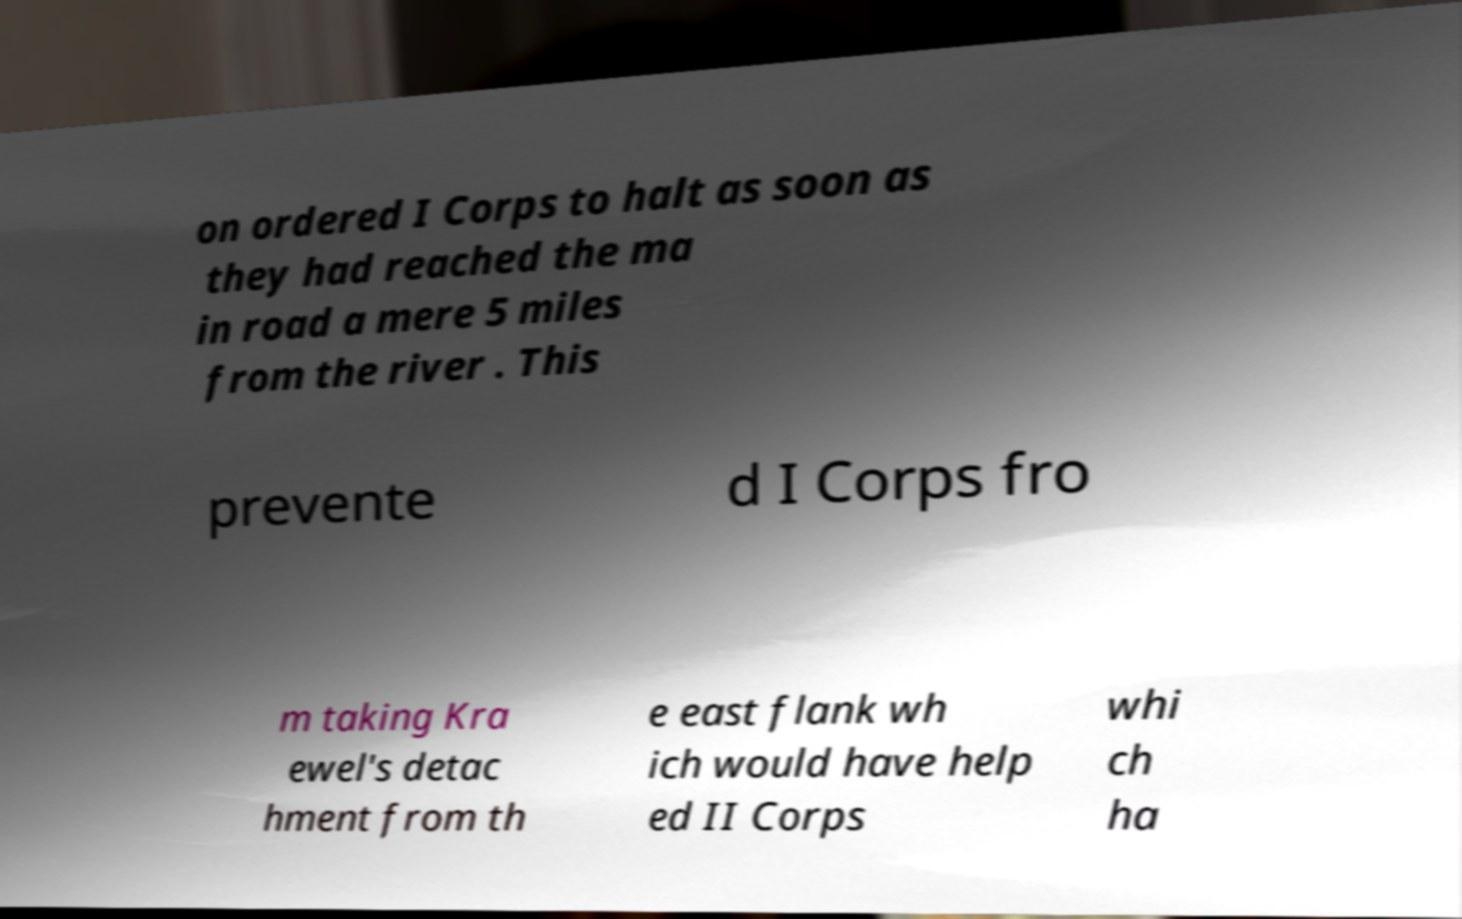Can you accurately transcribe the text from the provided image for me? on ordered I Corps to halt as soon as they had reached the ma in road a mere 5 miles from the river . This prevente d I Corps fro m taking Kra ewel's detac hment from th e east flank wh ich would have help ed II Corps whi ch ha 